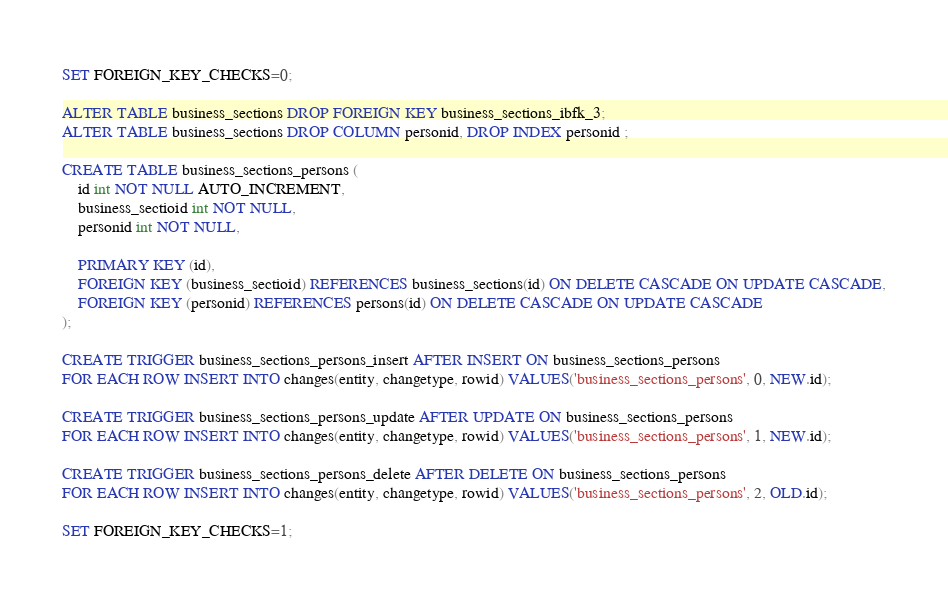Convert code to text. <code><loc_0><loc_0><loc_500><loc_500><_SQL_>SET FOREIGN_KEY_CHECKS=0;

ALTER TABLE business_sections DROP FOREIGN KEY business_sections_ibfk_3;
ALTER TABLE business_sections DROP COLUMN personid, DROP INDEX personid ;

CREATE TABLE business_sections_persons (
    id int NOT NULL AUTO_INCREMENT,
    business_sectioid int NOT NULL,
    personid int NOT NULL,

    PRIMARY KEY (id),
    FOREIGN KEY (business_sectioid) REFERENCES business_sections(id) ON DELETE CASCADE ON UPDATE CASCADE,
    FOREIGN KEY (personid) REFERENCES persons(id) ON DELETE CASCADE ON UPDATE CASCADE
);

CREATE TRIGGER business_sections_persons_insert AFTER INSERT ON business_sections_persons
FOR EACH ROW INSERT INTO changes(entity, changetype, rowid) VALUES('business_sections_persons', 0, NEW.id);

CREATE TRIGGER business_sections_persons_update AFTER UPDATE ON business_sections_persons
FOR EACH ROW INSERT INTO changes(entity, changetype, rowid) VALUES('business_sections_persons', 1, NEW.id);

CREATE TRIGGER business_sections_persons_delete AFTER DELETE ON business_sections_persons
FOR EACH ROW INSERT INTO changes(entity, changetype, rowid) VALUES('business_sections_persons', 2, OLD.id);

SET FOREIGN_KEY_CHECKS=1;
</code> 